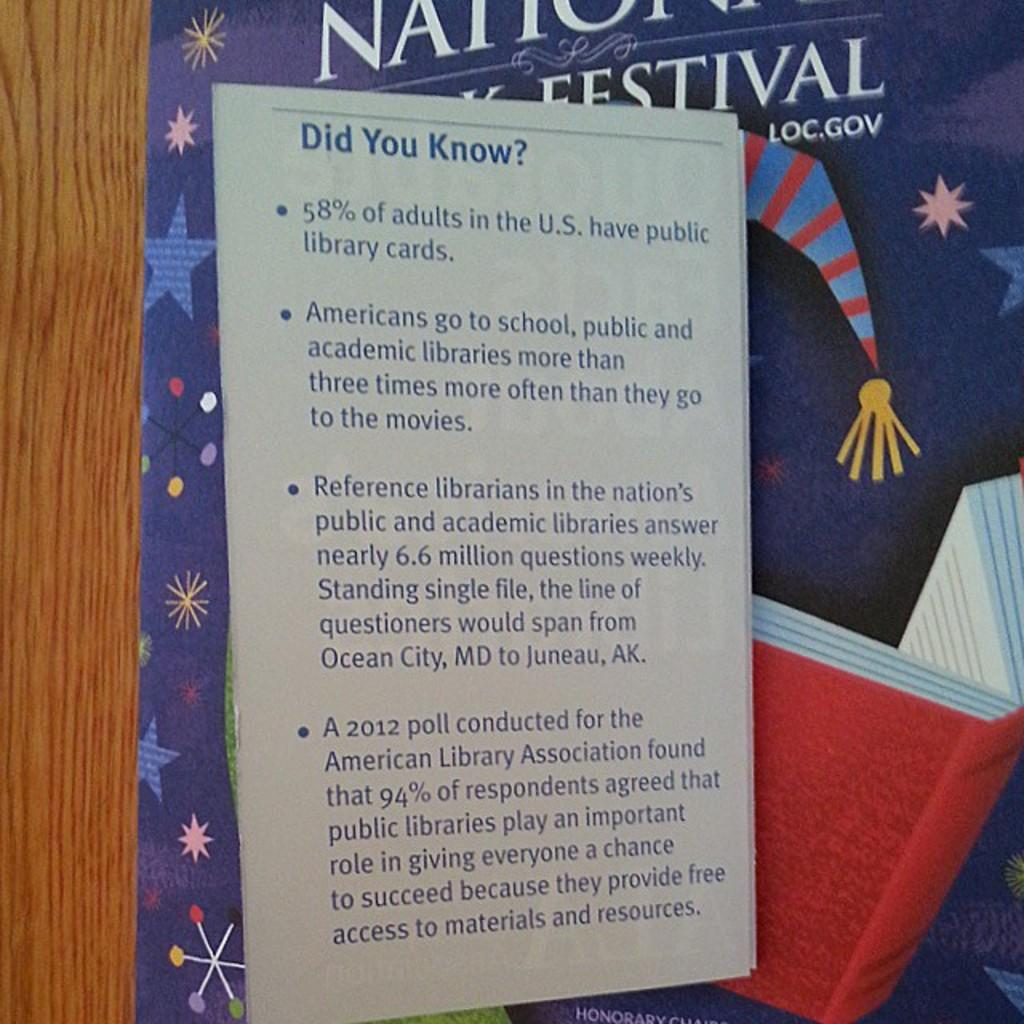<image>
Provide a brief description of the given image. a poster saying Did you Know in front of a blue and red striped hat picture 